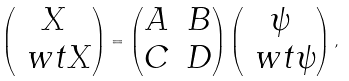<formula> <loc_0><loc_0><loc_500><loc_500>\left ( \begin{matrix} X \\ \ w t X \end{matrix} \right ) = \left ( \begin{matrix} A & B \\ C & D \end{matrix} \right ) \left ( \begin{matrix} \psi \\ \ w t \psi \end{matrix} \right ) ,</formula> 